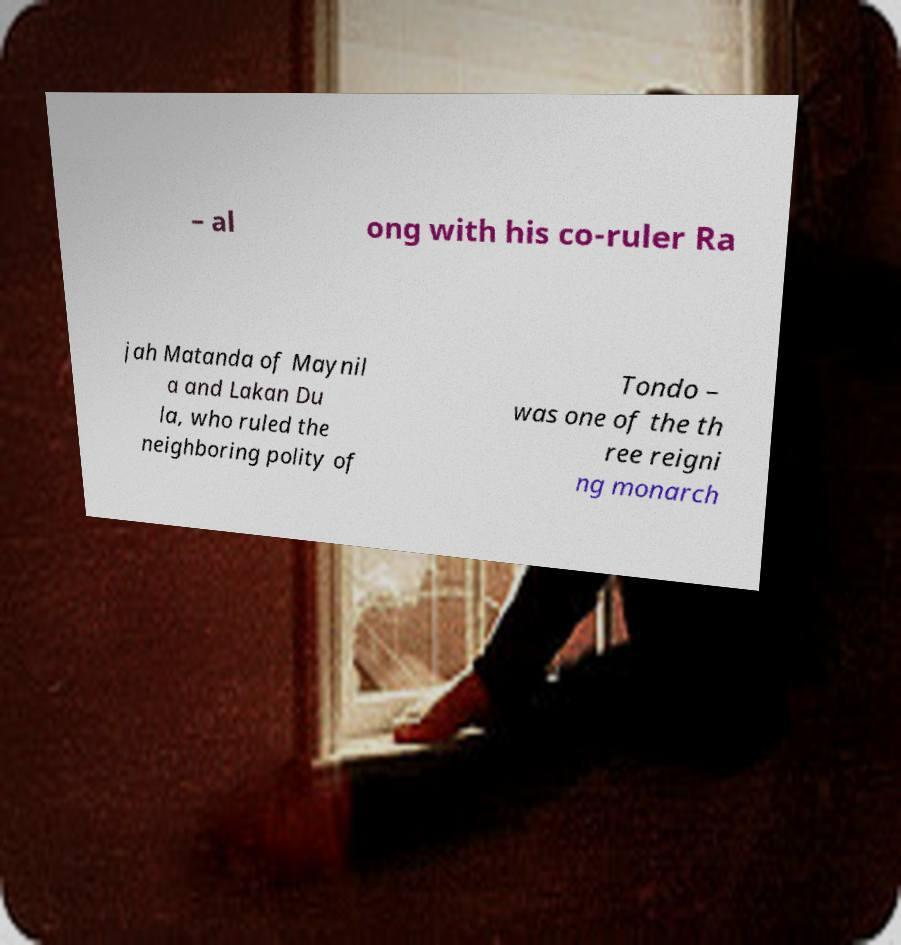Please read and relay the text visible in this image. What does it say? – al ong with his co-ruler Ra jah Matanda of Maynil a and Lakan Du la, who ruled the neighboring polity of Tondo – was one of the th ree reigni ng monarch 